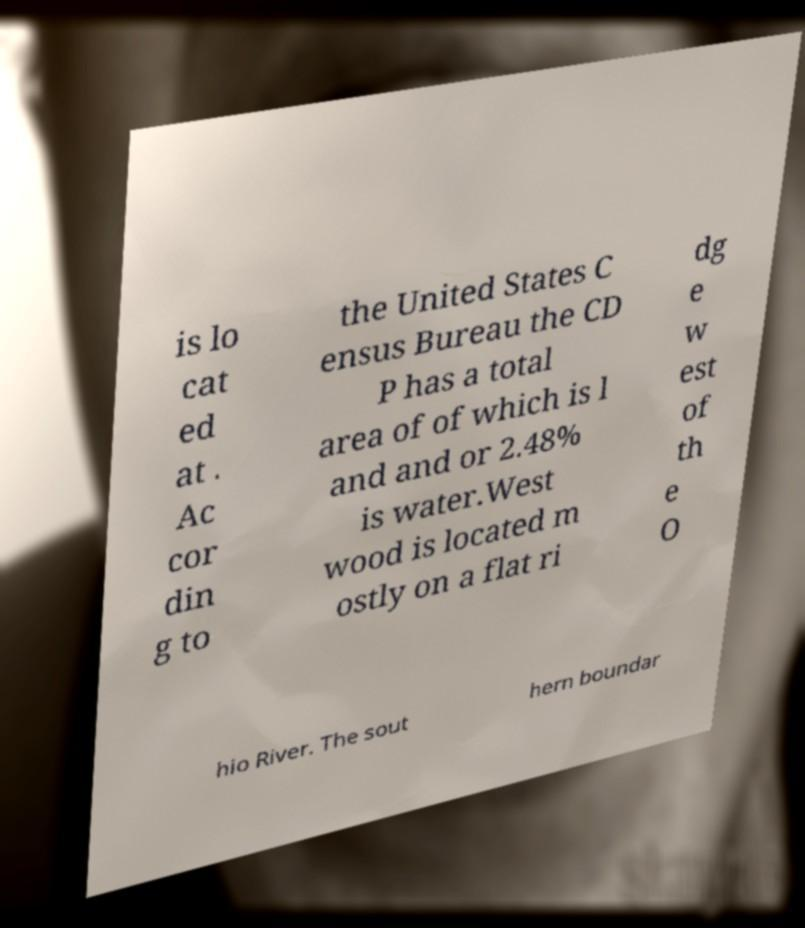Please read and relay the text visible in this image. What does it say? is lo cat ed at . Ac cor din g to the United States C ensus Bureau the CD P has a total area of of which is l and and or 2.48% is water.West wood is located m ostly on a flat ri dg e w est of th e O hio River. The sout hern boundar 